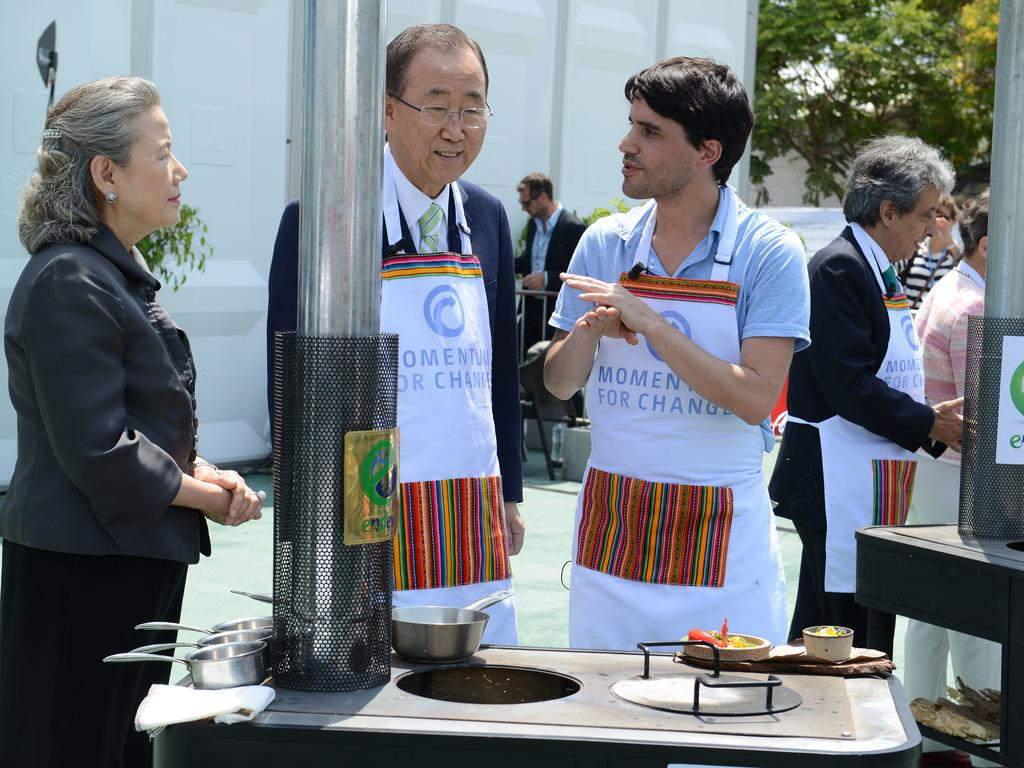What is happening in the image? There are people standing in the image. What objects are visible in the image? There are bowls visible in the image. What else can be seen in the image besides people and bowls? There are food items in the image. What type of music can be heard coming from the window in the image? There is no window or music present in the image; it only features people, bowls, and food items. 